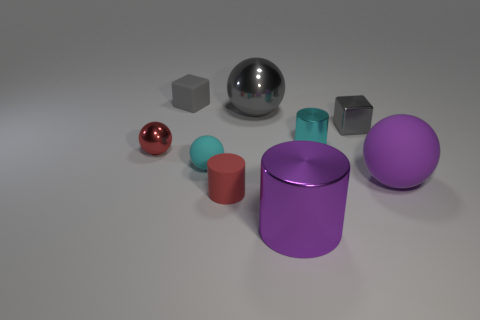Subtract all big purple metal cylinders. How many cylinders are left? 2 Subtract 1 cylinders. How many cylinders are left? 2 Subtract all red cylinders. How many cylinders are left? 2 Add 3 tiny red matte cylinders. How many tiny red matte cylinders are left? 4 Add 4 metal balls. How many metal balls exist? 6 Subtract 0 red blocks. How many objects are left? 9 Subtract all balls. How many objects are left? 5 Subtract all gray spheres. Subtract all yellow cylinders. How many spheres are left? 3 Subtract all red spheres. Subtract all tiny red metal things. How many objects are left? 7 